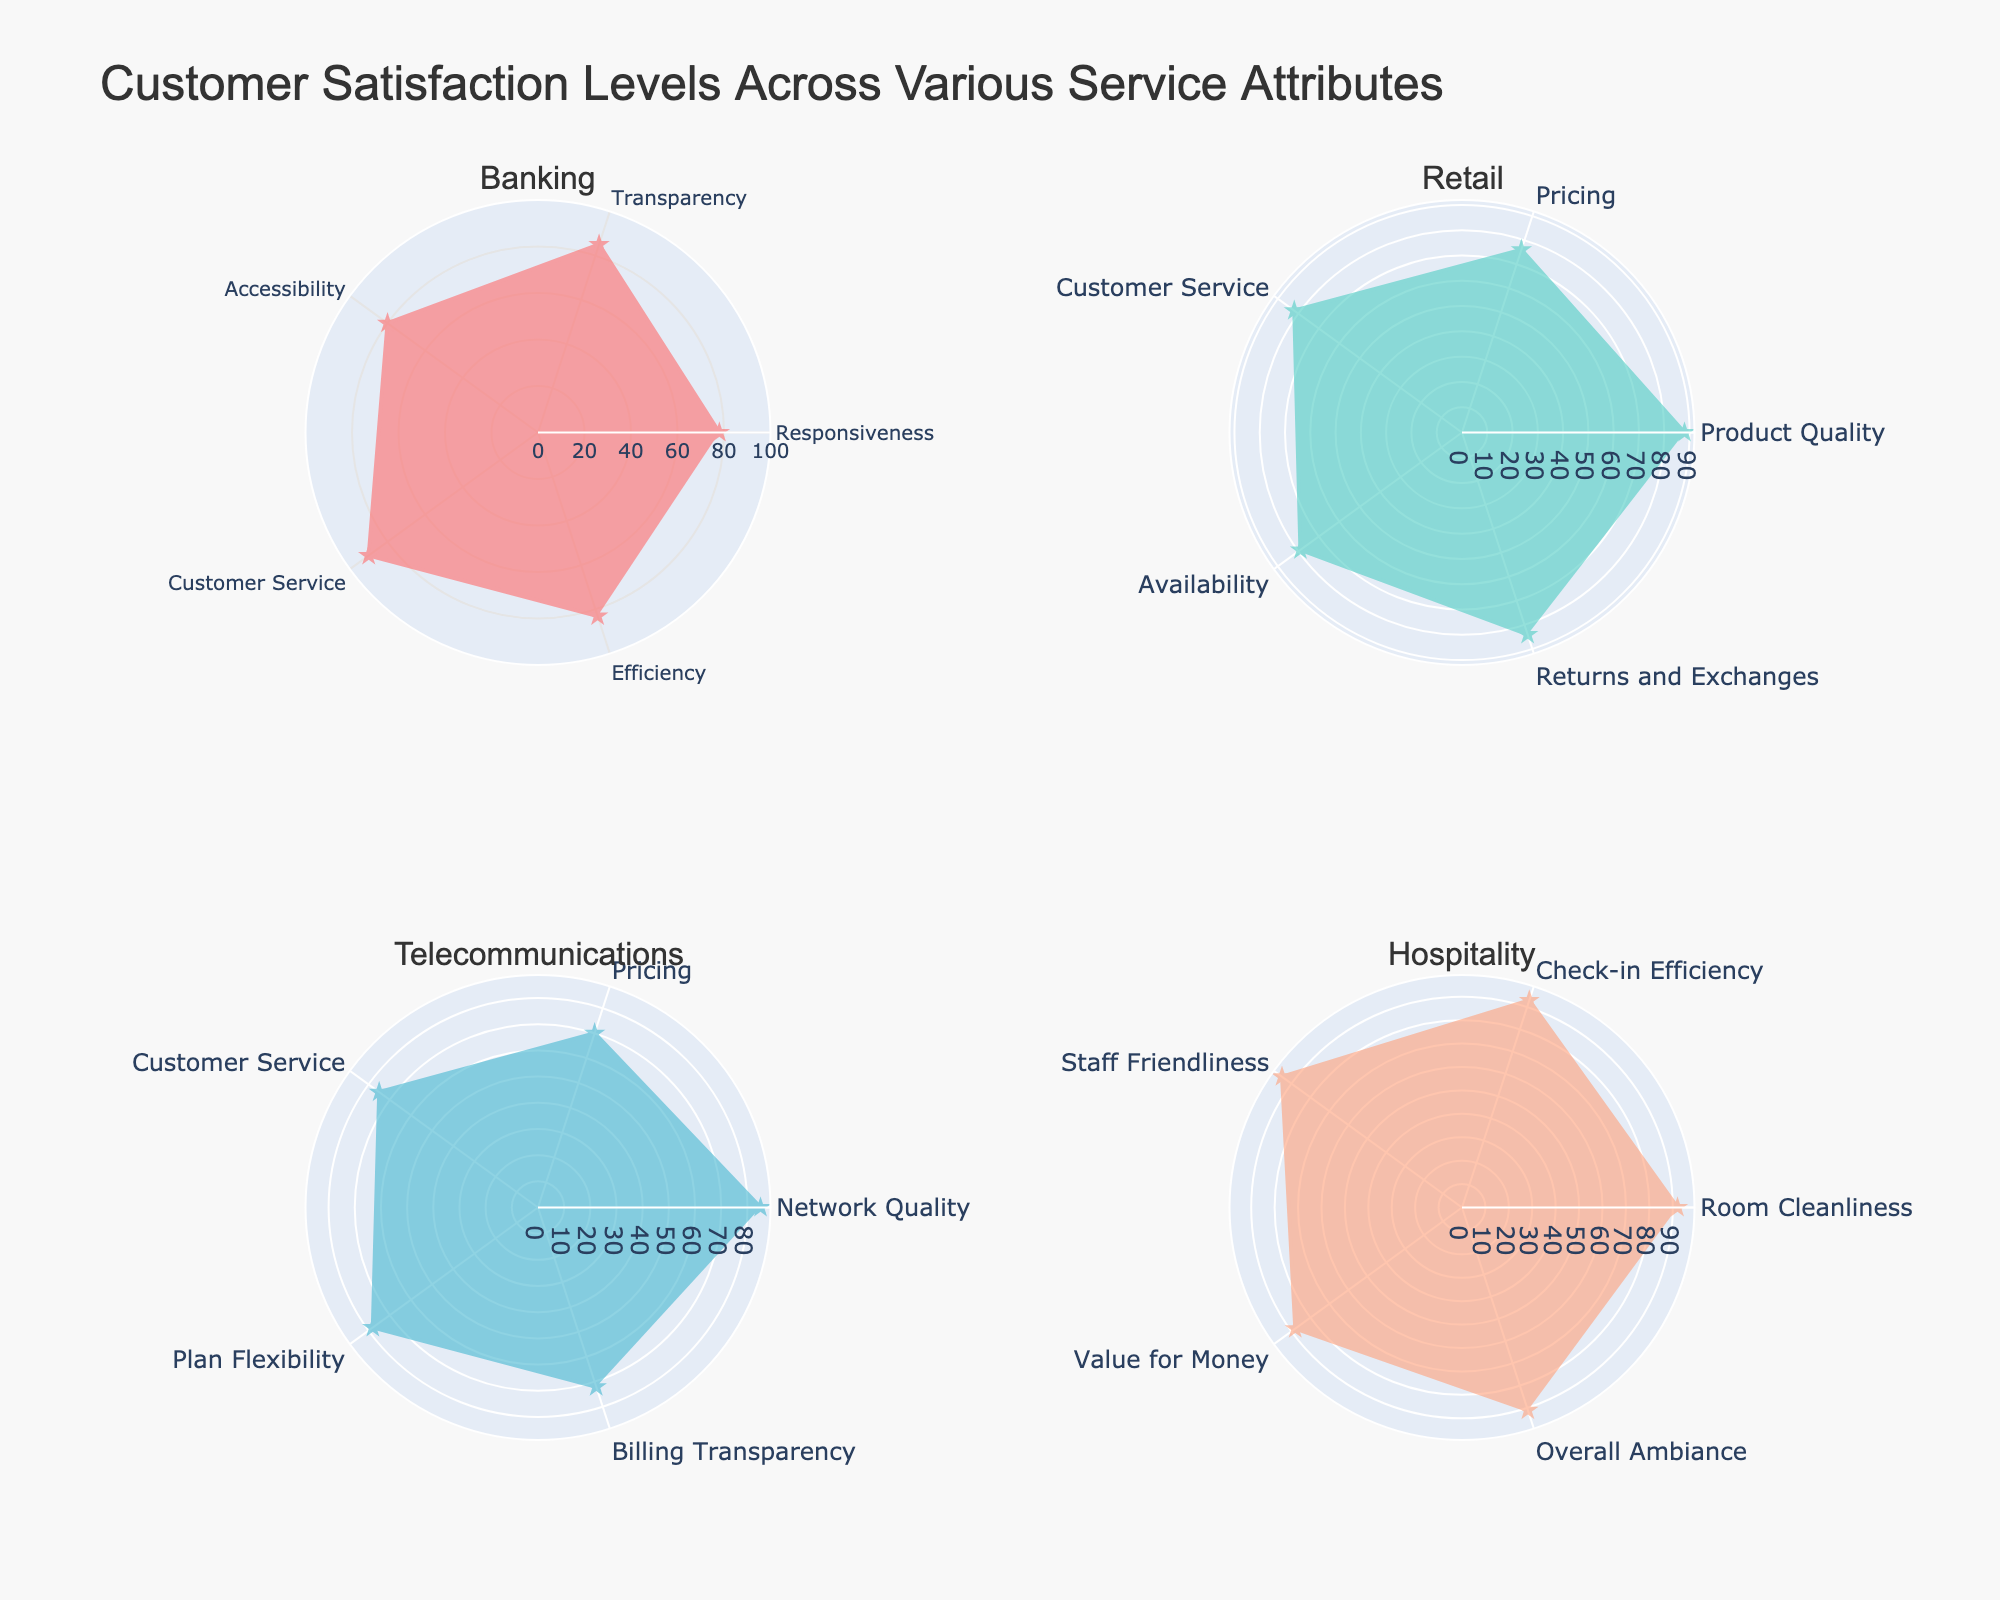What is the title of the figure? The title of the figure is usually located at the top center. By examining the figure, the title text reads "Customer Satisfaction Levels Across Various Service Attributes"
Answer: Customer Satisfaction Levels Across Various Service Attributes How many service attributes are represented for the Banking category? Looking at the subplot for Banking, the number of distinct attributes or sectors in the polar chart is seen by counting the labeled axes. There are five attributes: Responsiveness, Transparency, Accessibility, Customer Service, and Efficiency.
Answer: 5 Which category shows the highest customer satisfaction level for any attribute, and what is that level? Examine each subplot to find the highest peak on each chart. In Hospitality, "Staff Friendliness" has a customer satisfaction level of 95, which is the highest among all categories and attributes.
Answer: Hospitality, 95 Compare the customer satisfaction levels for 'Customer Service' across all categories. Which category has the highest level and which has the lowest? From each subplot, extract the values for the 'Customer Service' attribute. Banking has 90, Retail has 82, Telecommunications has 75, and Hospitality does not have this attribute. Therefore, the highest is in Banking (90) and the lowest is in Telecommunications (75).
Answer: Highest: Banking, 90; Lowest: Telecommunications, 75 Which category has the most uniform customer satisfaction levels across its attributes? By examining the shape of each polar plot, we can identify which plot has the most balanced or square-like shape, indicating uniform satisfaction levels. Hospitality shows the most uniform levels, as its vertices are closer to forming a regular shape with relatively small differences between values.
Answer: Hospitality What is the difference between the highest and lowest customer satisfaction levels in Telecommunications? Identify the highest and lowest points in the Telecommunications subplot. The highest is Network Quality (85) and the lowest is Pricing (70). The difference is 85 - 70 = 15.
Answer: 15 Which category has the largest variability in customer satisfaction levels across its attributes? To determine variability, observe the range (distance from highest to lowest values) of satisfaction scores. Telecommunications shows the widest range, from 70 (Pricing) to 85 (Network Quality), a range of 15. This is higher than the ranges observed in other categories.
Answer: Telecommunications What color represents Banking on the polar charts? Each category is represented by a different color. By examining the Banking subplot, the color representing Banking is a specific shade used in the plot, which in this case is red.
Answer: Red Which attribute has the lowest level of customer satisfaction in Retail? In the Retail subplot, the lowest point on the chart represents the attribute with the lowest satisfaction. Pricing has the lowest level of satisfaction with a score of 76.
Answer: Pricing, 76 